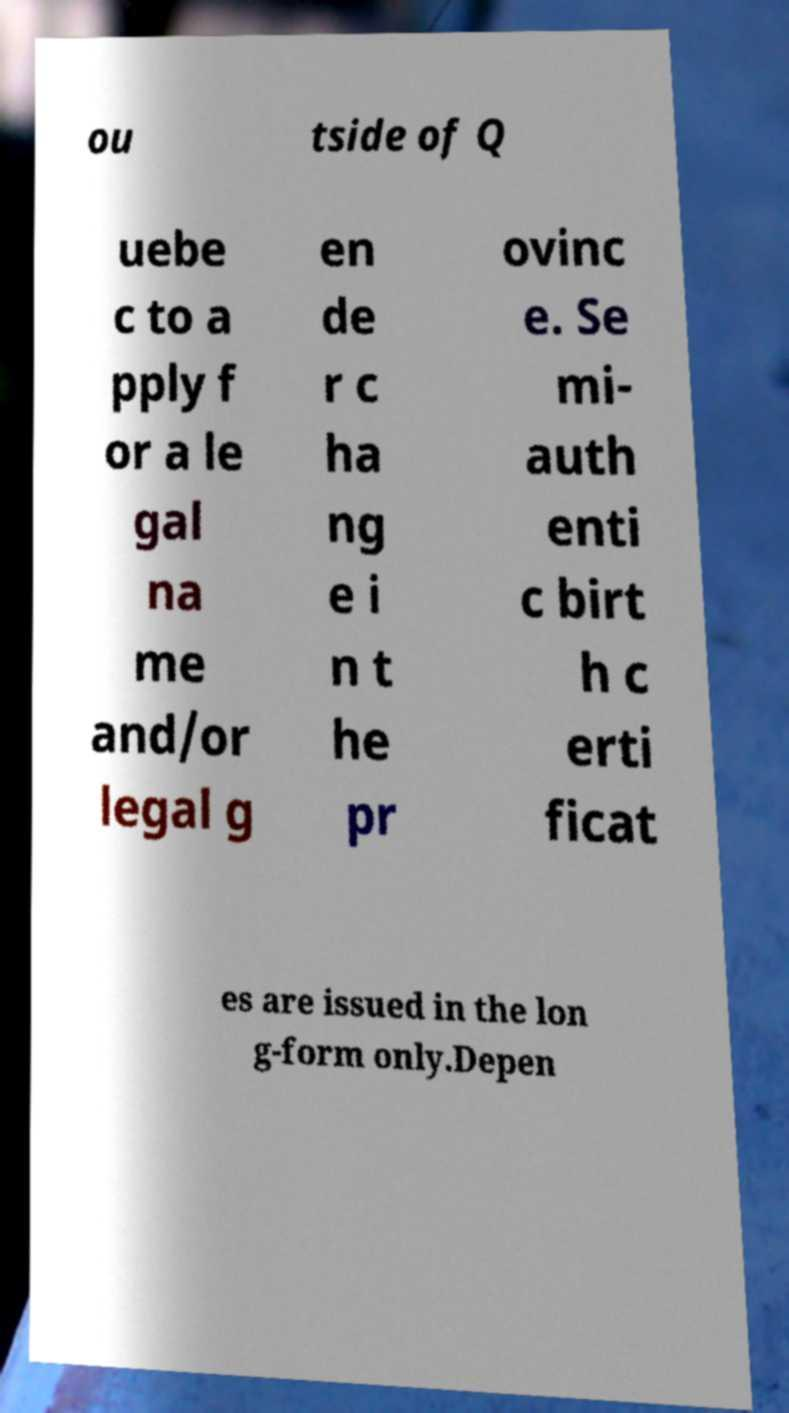Can you accurately transcribe the text from the provided image for me? ou tside of Q uebe c to a pply f or a le gal na me and/or legal g en de r c ha ng e i n t he pr ovinc e. Se mi- auth enti c birt h c erti ficat es are issued in the lon g-form only.Depen 